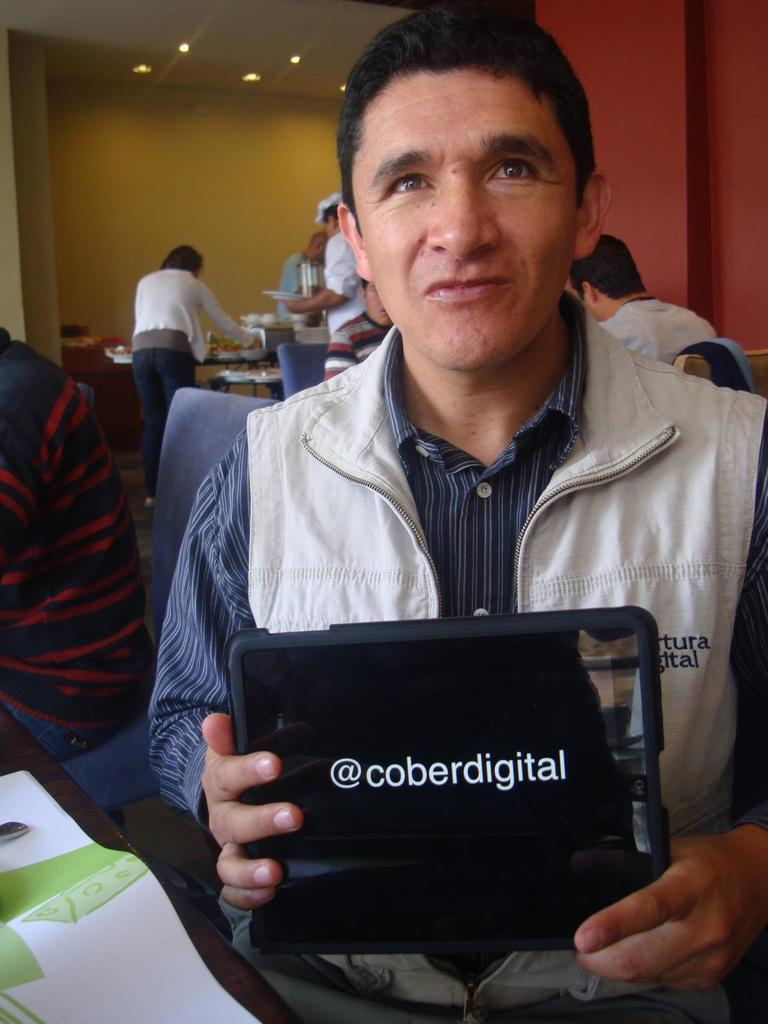What is the man in the image doing? The man is sitting in a chair at a table. What is the man holding in his hands? The man is holding a tab in his hands. Can you describe the background of the image? There are people in the background of the image. How many brothers does the man have in the image? There is no information about the man's brothers in the image. What type of pet is sitting next to the man in the image? There is no pet present in the image. 